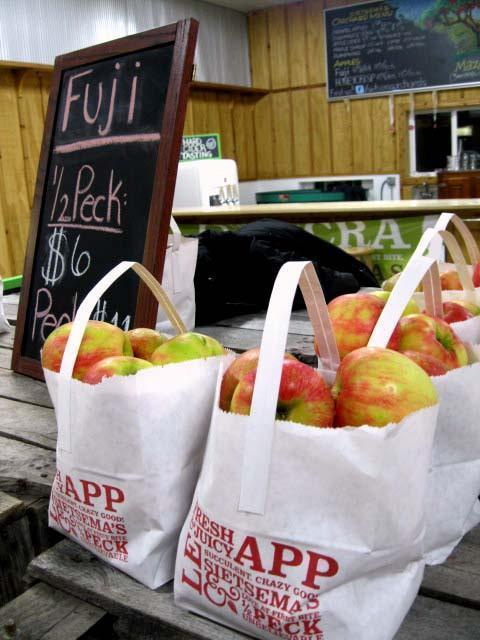How many apples can you see?
Give a very brief answer. 4. How many sinks are visible?
Give a very brief answer. 0. 